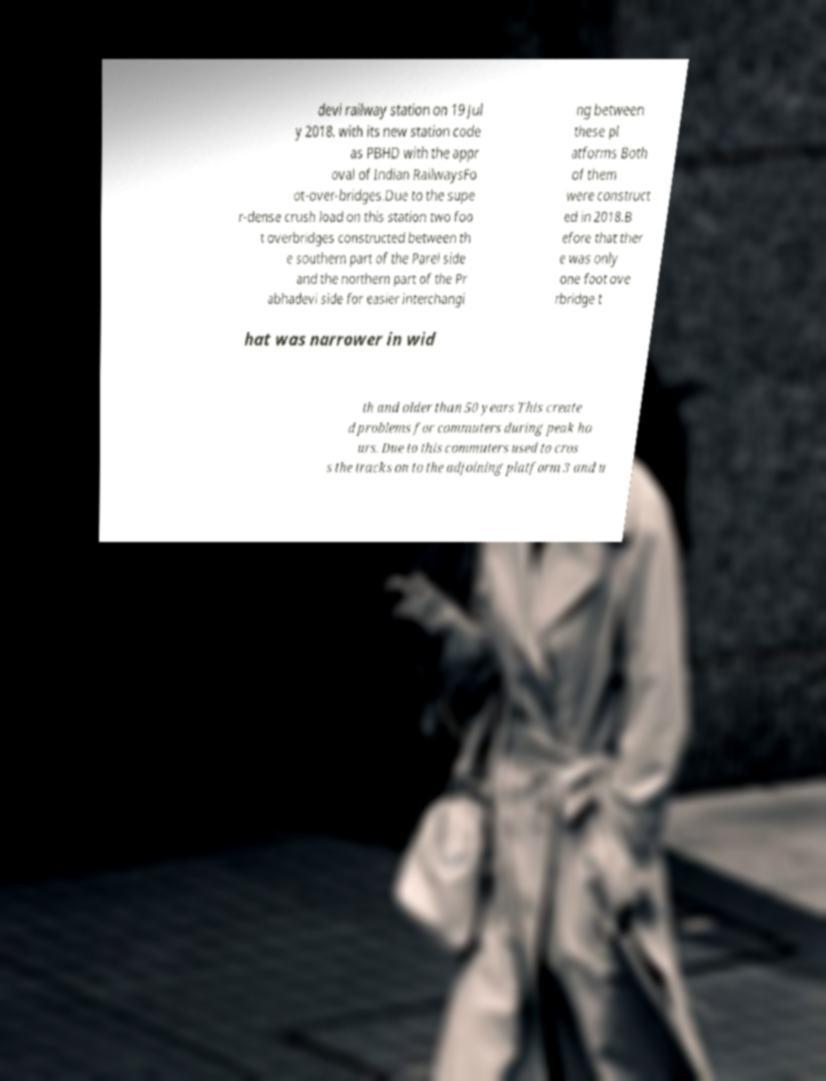Can you accurately transcribe the text from the provided image for me? devi railway station on 19 Jul y 2018. with its new station code as PBHD with the appr oval of Indian RailwaysFo ot-over-bridges.Due to the supe r-dense crush load on this station two foo t overbridges constructed between th e southern part of the Parel side and the northern part of the Pr abhadevi side for easier interchangi ng between these pl atforms Both of them were construct ed in 2018.B efore that ther e was only one foot ove rbridge t hat was narrower in wid th and older than 50 years This create d problems for commuters during peak ho urs. Due to this commuters used to cros s the tracks on to the adjoining platform 3 and u 